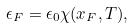Convert formula to latex. <formula><loc_0><loc_0><loc_500><loc_500>\epsilon _ { F } = \epsilon _ { 0 } \chi ( x _ { F } , T ) ,</formula> 